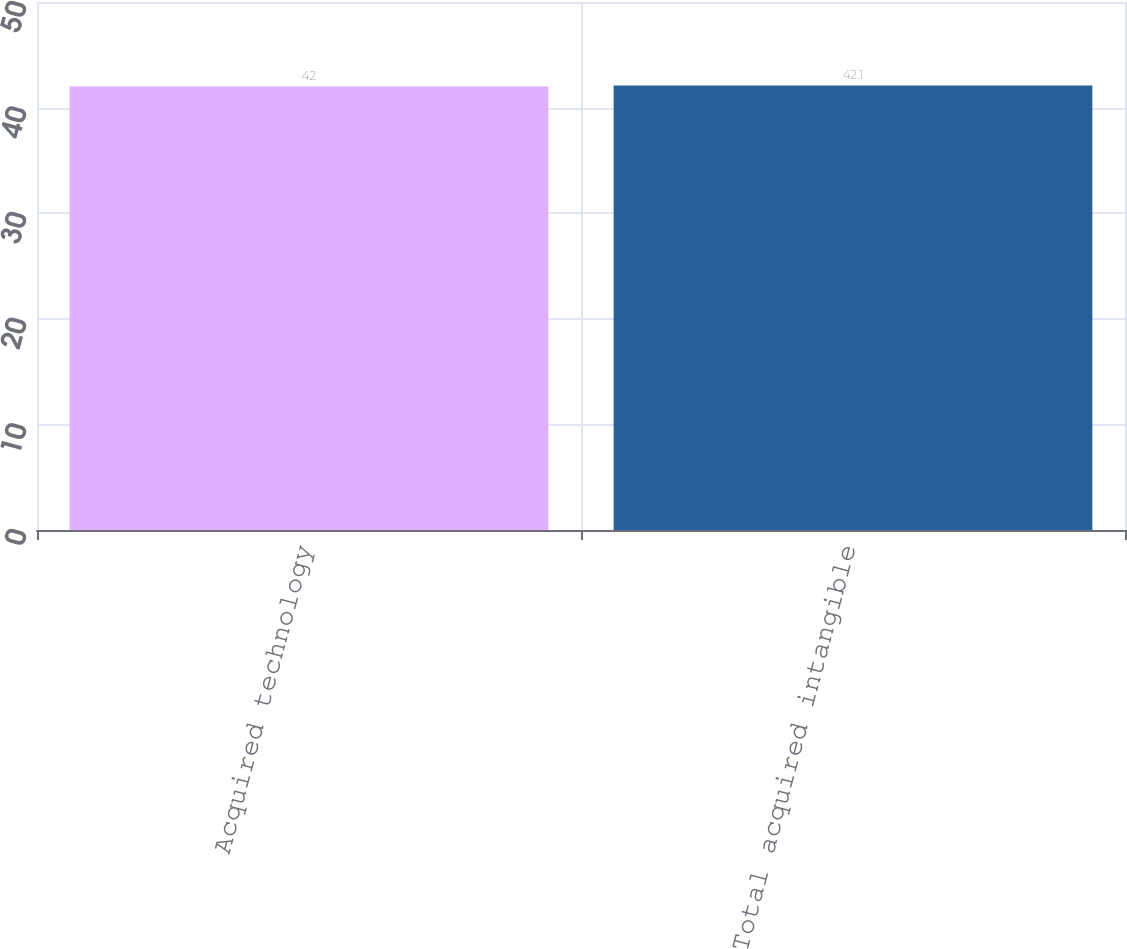Convert chart. <chart><loc_0><loc_0><loc_500><loc_500><bar_chart><fcel>Acquired technology<fcel>Total acquired intangible<nl><fcel>42<fcel>42.1<nl></chart> 